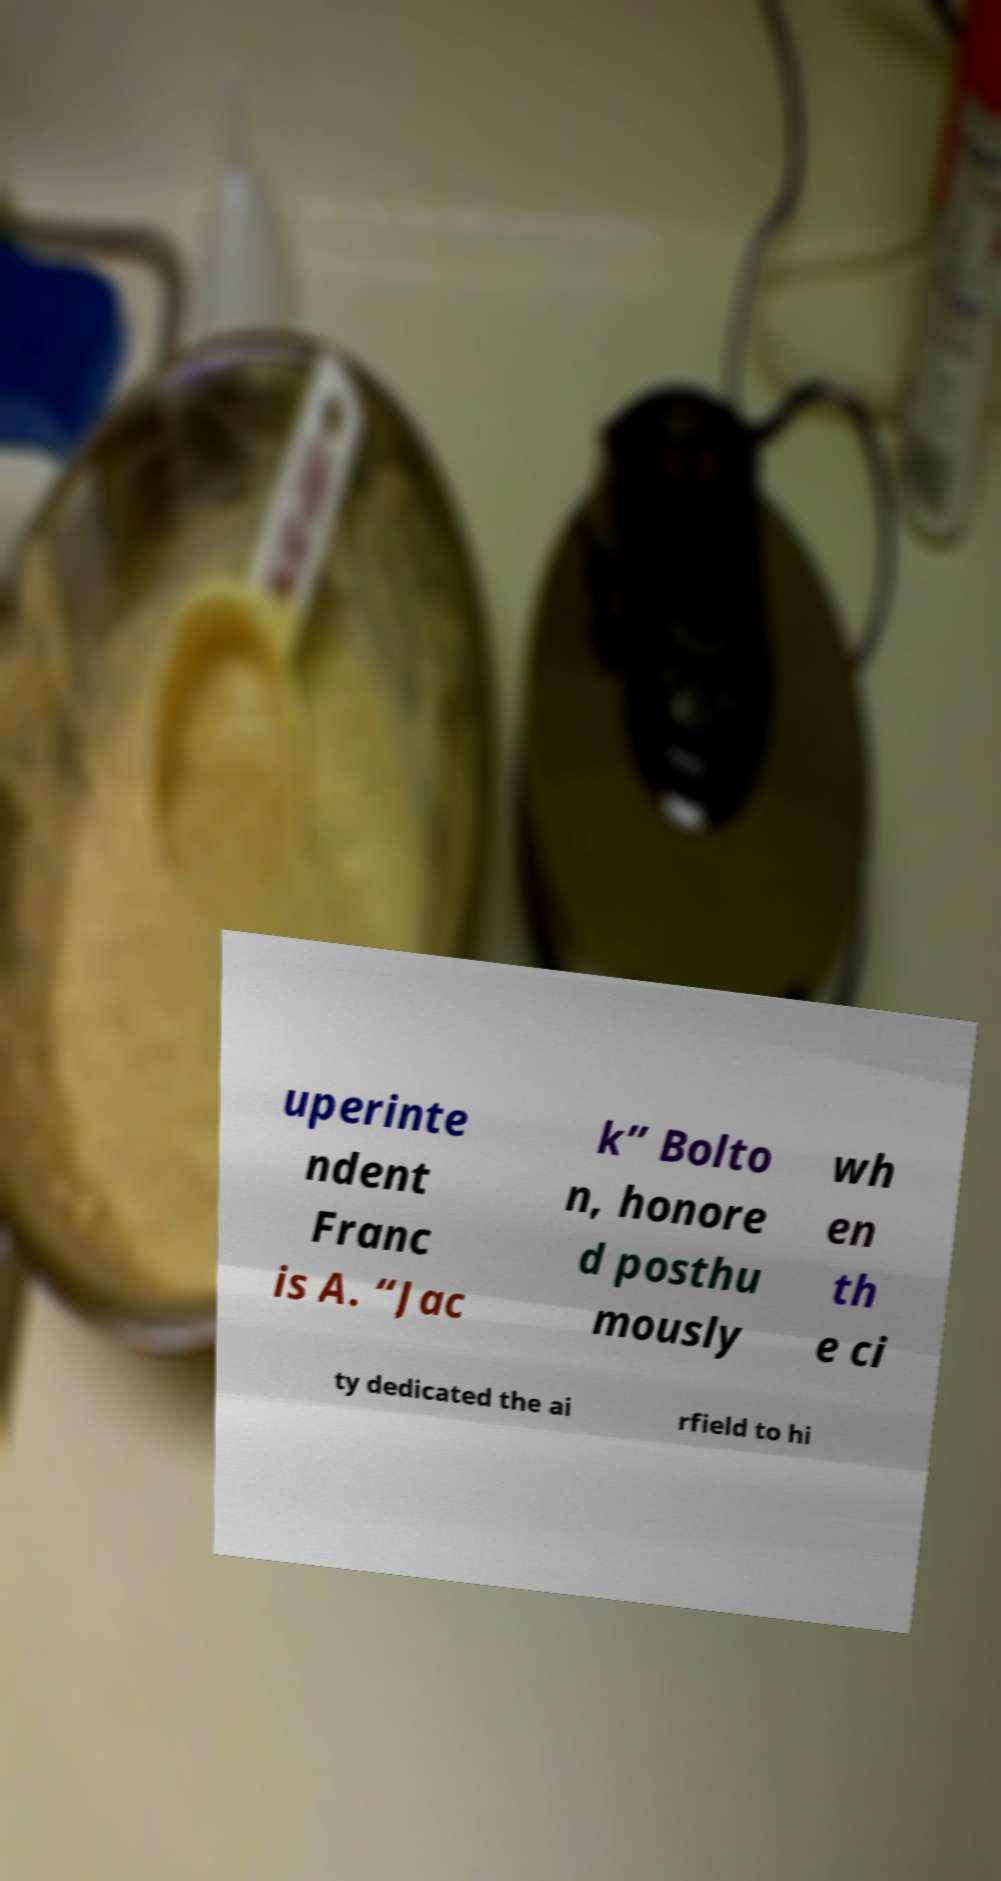There's text embedded in this image that I need extracted. Can you transcribe it verbatim? uperinte ndent Franc is A. “Jac k” Bolto n, honore d posthu mously wh en th e ci ty dedicated the ai rfield to hi 